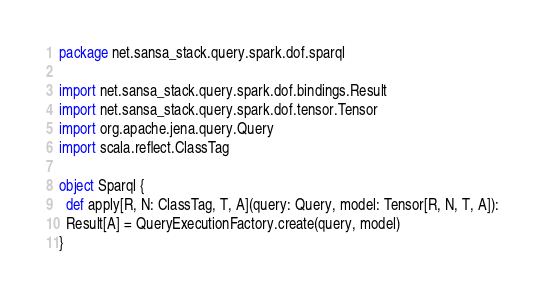Convert code to text. <code><loc_0><loc_0><loc_500><loc_500><_Scala_>package net.sansa_stack.query.spark.dof.sparql

import net.sansa_stack.query.spark.dof.bindings.Result
import net.sansa_stack.query.spark.dof.tensor.Tensor
import org.apache.jena.query.Query
import scala.reflect.ClassTag

object Sparql {
  def apply[R, N: ClassTag, T, A](query: Query, model: Tensor[R, N, T, A]):
  Result[A] = QueryExecutionFactory.create(query, model)
}
</code> 